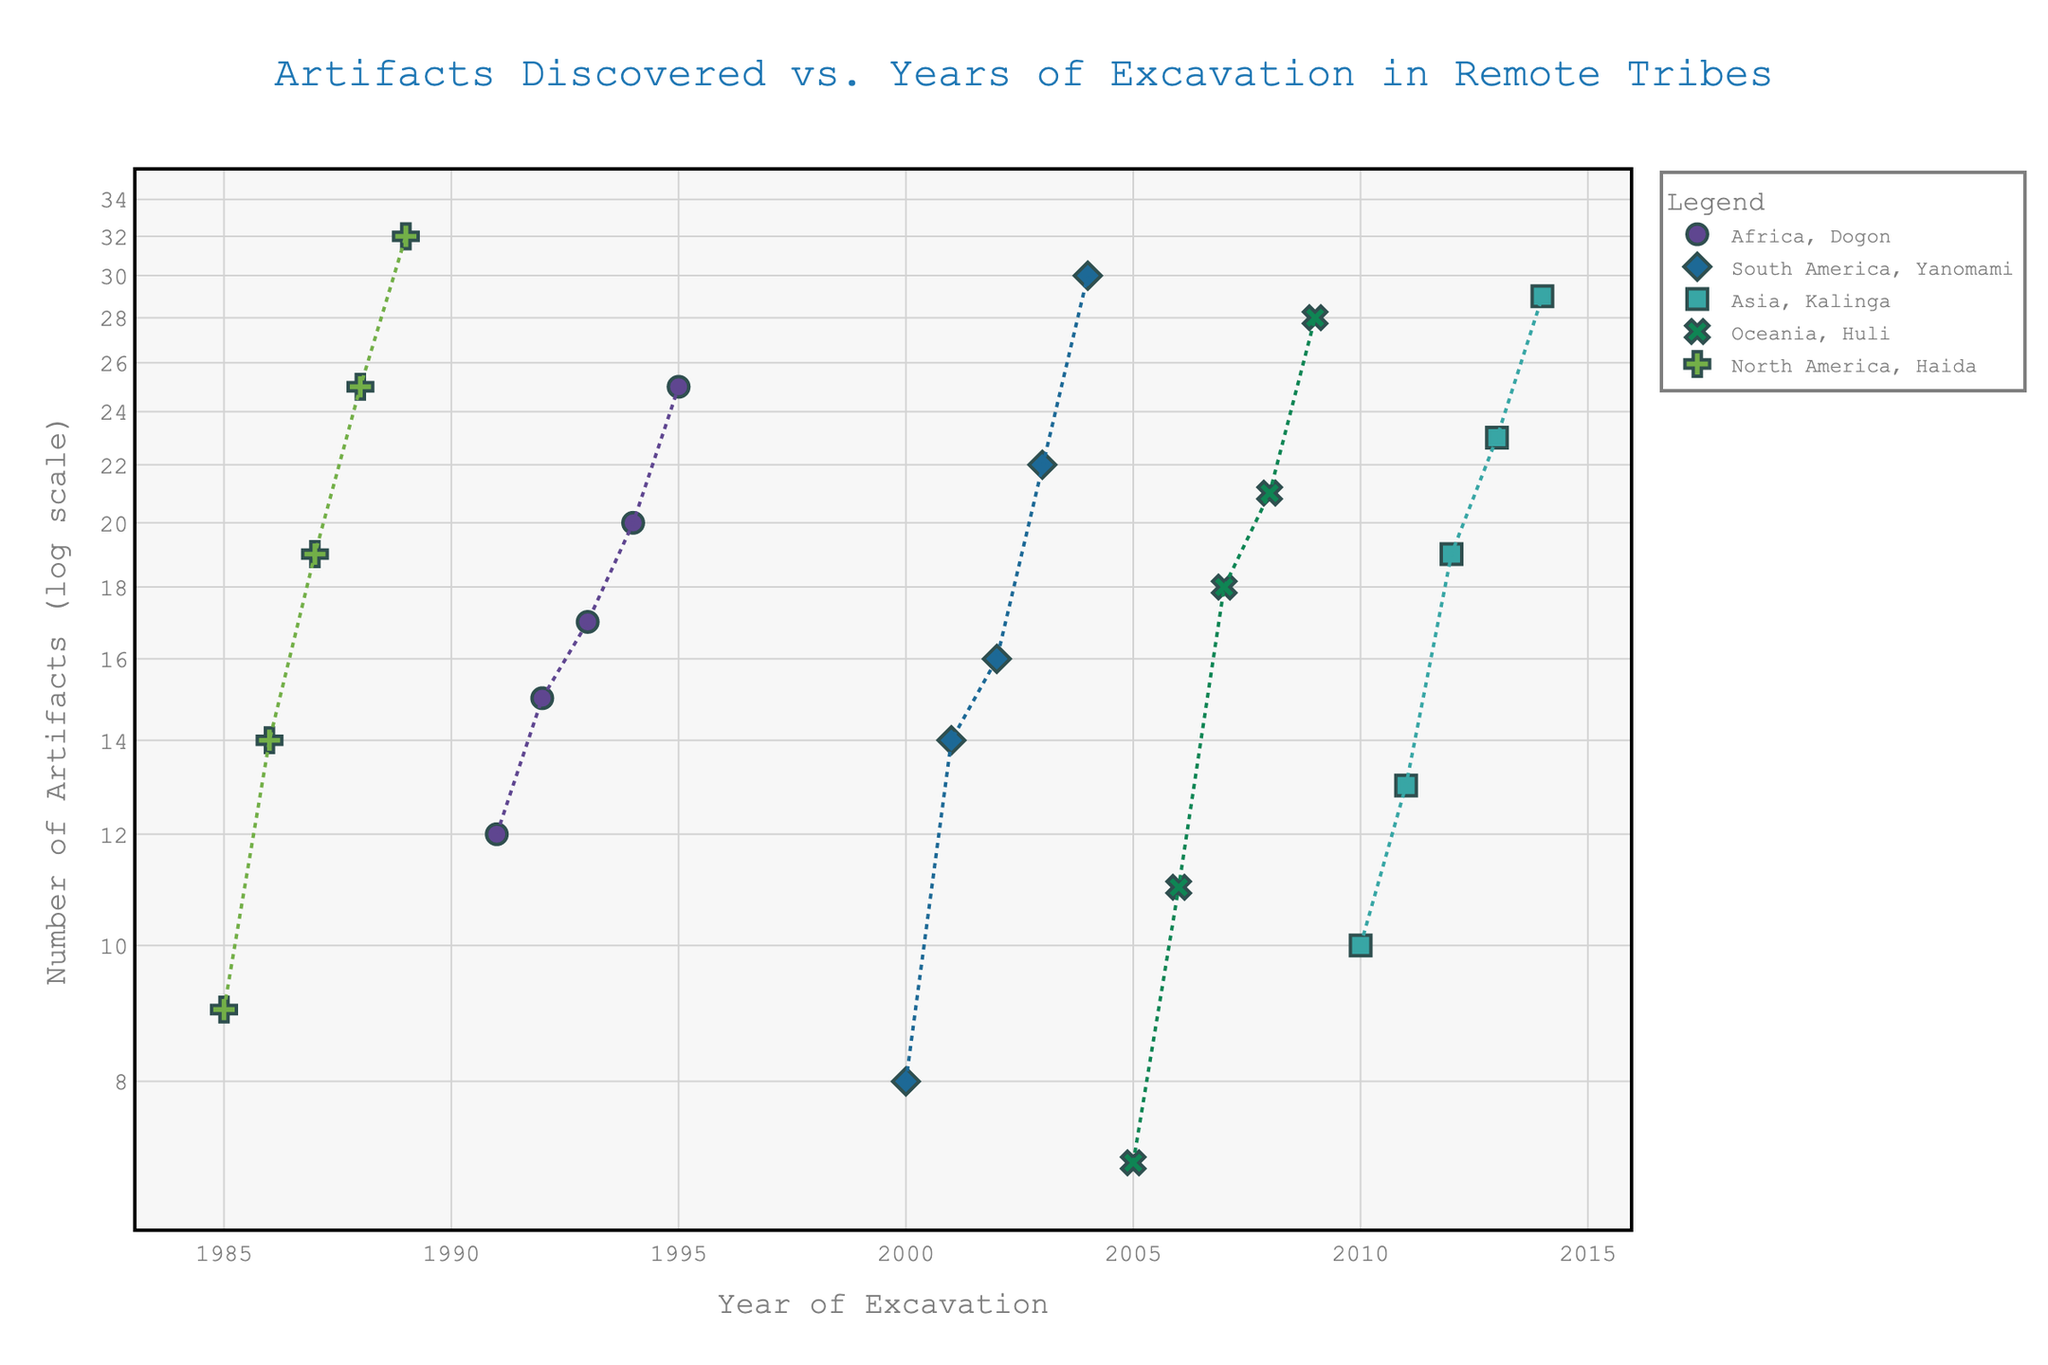What is the title of the scatter plot? The title is typically positioned at the top of the plot and summarizes the main idea of the visualization.
Answer: Artifacts Discovered vs. Years of Excavation in Remote Tribes What colors are used to represent the different continents in the scatter plot? Different colors represent different continents to easily distinguish between them. The plot legend tells us which color corresponds to which continent.
Answer: Africa, South America, Asia, Oceania, North America (color details are not visually visible in this context) On what axis is the number of artifacts discovered represented and in what scale? The y-axis represents the number of artifacts discovered and it is shown in a log scale in the plot.
Answer: y-axis, log scale Which tribe discovered the highest number of artifacts by the end of the observations? From the data points on the plot, identify which tribe's highest data point on the y-axis is the largest number of artifacts discovered.
Answer: Haida How many tribes are represented from the continent of Africa, and what is the trend over the years of excavation? By filtering the data points corresponding to Africa and noting the distinct tribe symbols, we count the tribes and observe any increasing or decreasing trend over the years.
Answer: 1 tribe (Dogon); increasing trend Which tribe has the most noticeable increase in artifacts discovered over time? Observe the slope of the trend lines and look for the tribe with the steepest incline.
Answer: Haida What can be inferred about the trend of artifacts discovered in the Oceania continent? Identify the data points and trend line associated with the Oceania continent and observe the pattern over the years.
Answer: Increasing trend Comparing the years 2002 and 2003, which tribe discovered the most artifacts in 2003? Look for the data points corresponding to the year 2003 and compare the values amongst different tribes.
Answer: Yanomami What is the period with the least artifacts discovered by the Huli tribe, and how many were discovered in that year? Identify the data points corresponding to the Huli tribe and find the year with the lowest value on the y-axis.
Answer: 2005; 7 artifacts Compare the starting number of artifacts discovered by the Dogon and Yanomami tribes. Which one had a lower starting point? Identify the first data point for both tribes and compare their values.
Answer: Yanomami 